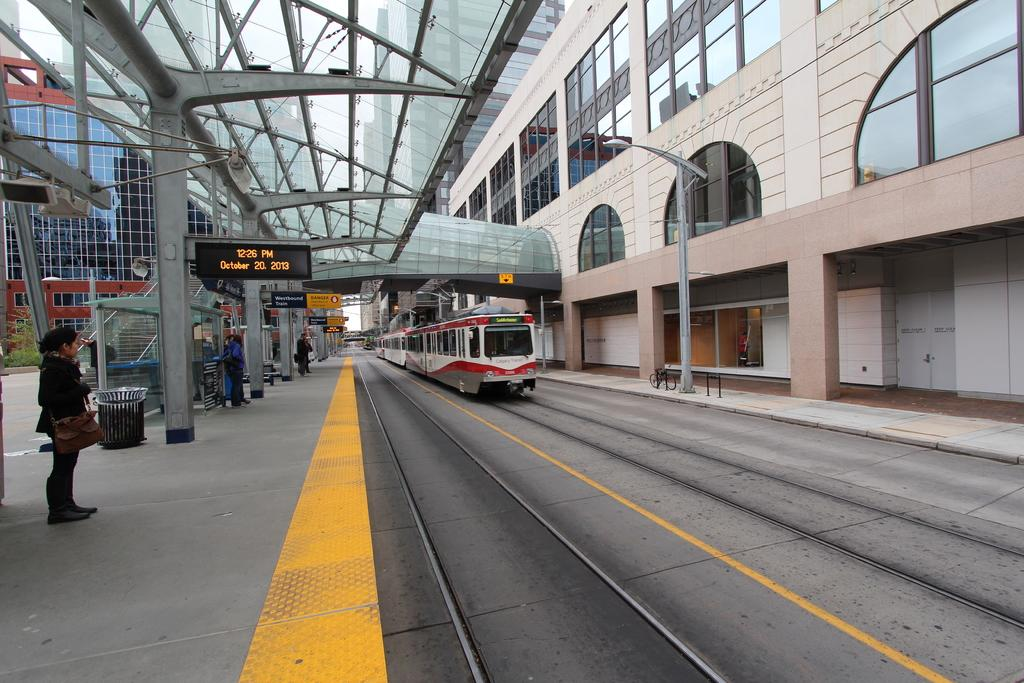What mode of transportation is visible on the right side of the image? There is a train on the right side of the image. Where is the train located in the image? The train is on a railway track. What are the people on the left side of the image doing? The people are waiting on the left side of the image. Where are the people waiting? The people are on a platform. Can you see a guitar being played by someone on the platform in the image? There is no guitar or anyone playing it in the image. 